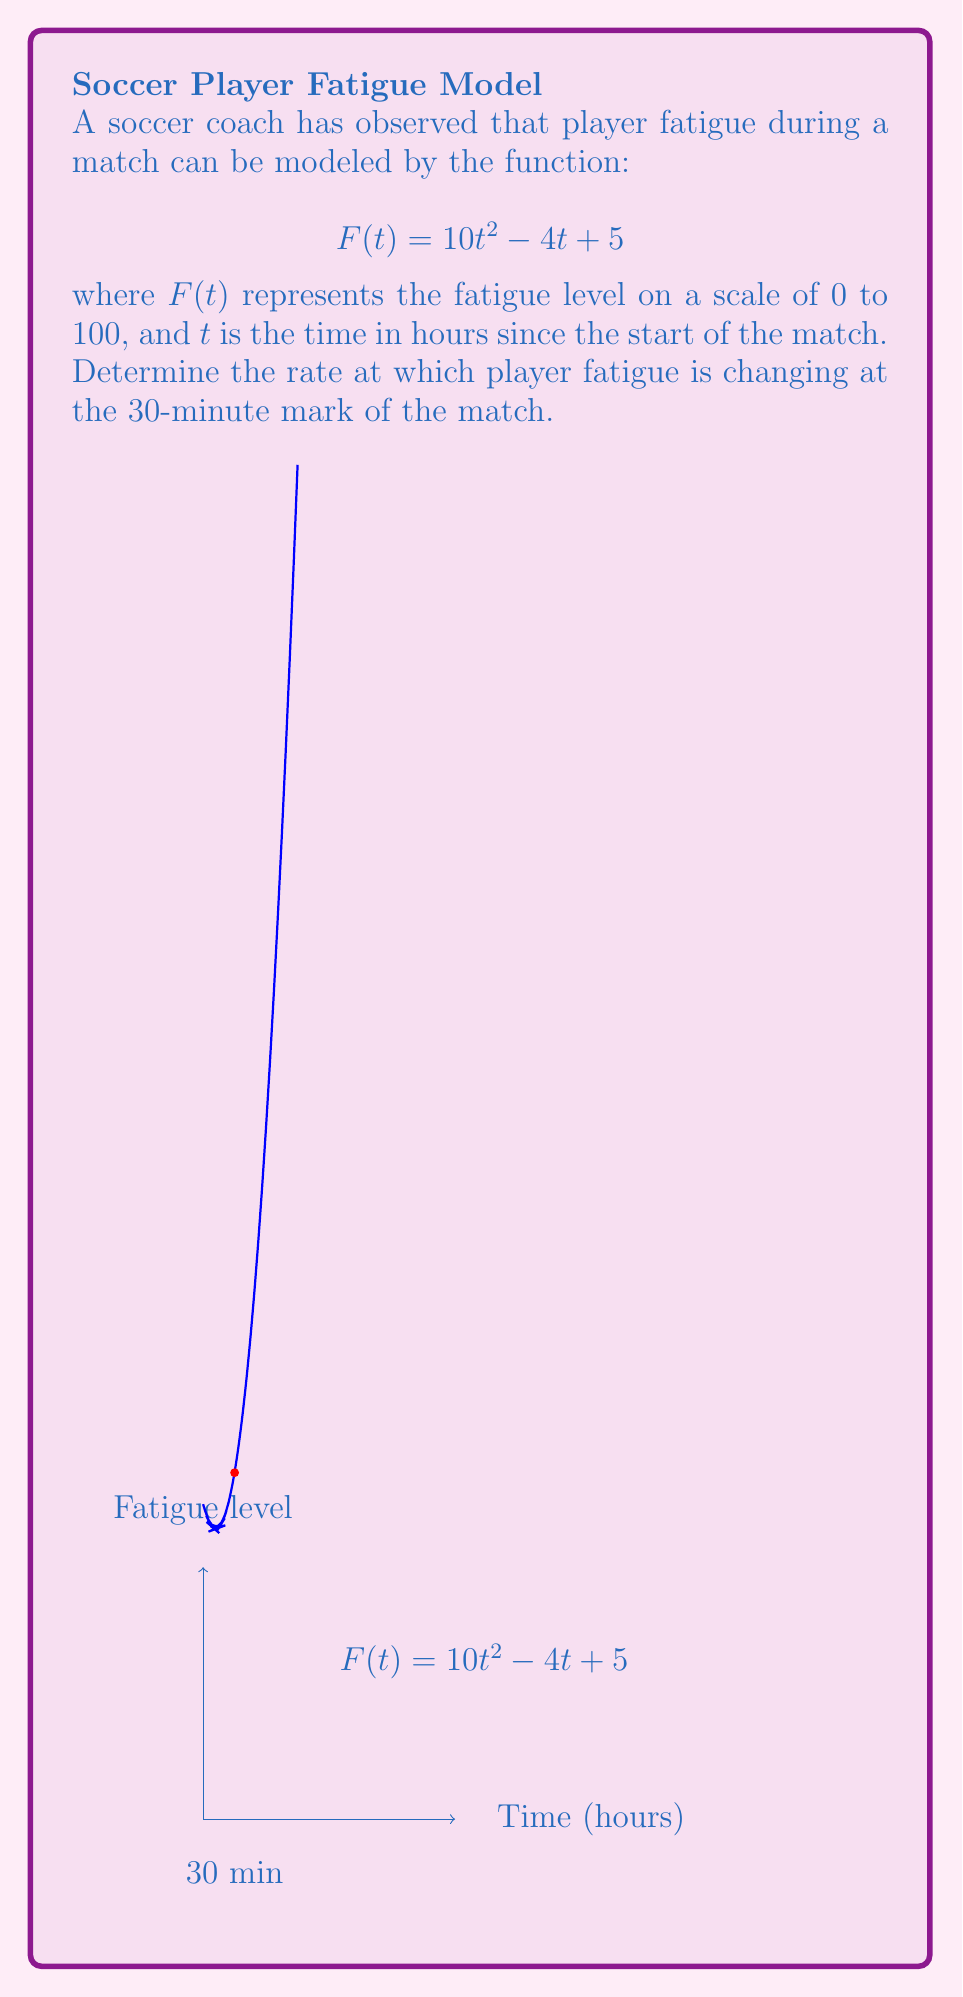Teach me how to tackle this problem. To solve this problem, we need to find the derivative of the fatigue function and evaluate it at the 30-minute mark. Let's break it down step-by-step:

1) The given function is $F(t) = 10t^2 - 4t + 5$

2) To find the rate of change, we need to differentiate $F(t)$ with respect to $t$:
   $$F'(t) = \frac{d}{dt}(10t^2 - 4t + 5)$$
   $$F'(t) = 20t - 4$$

3) Now, we need to evaluate $F'(t)$ at the 30-minute mark. However, our function is in terms of hours, so we need to convert 30 minutes to hours:
   30 minutes = 0.5 hours

4) Let's substitute $t = 0.5$ into our derivative function:
   $$F'(0.5) = 20(0.5) - 4$$
   $$F'(0.5) = 10 - 4 = 6$$

5) Therefore, at the 30-minute mark, the rate of change of player fatigue is 6 units per hour.

This positive rate indicates that fatigue is increasing, which aligns with the expectation that players become more tired as the match progresses.
Answer: 6 units per hour 